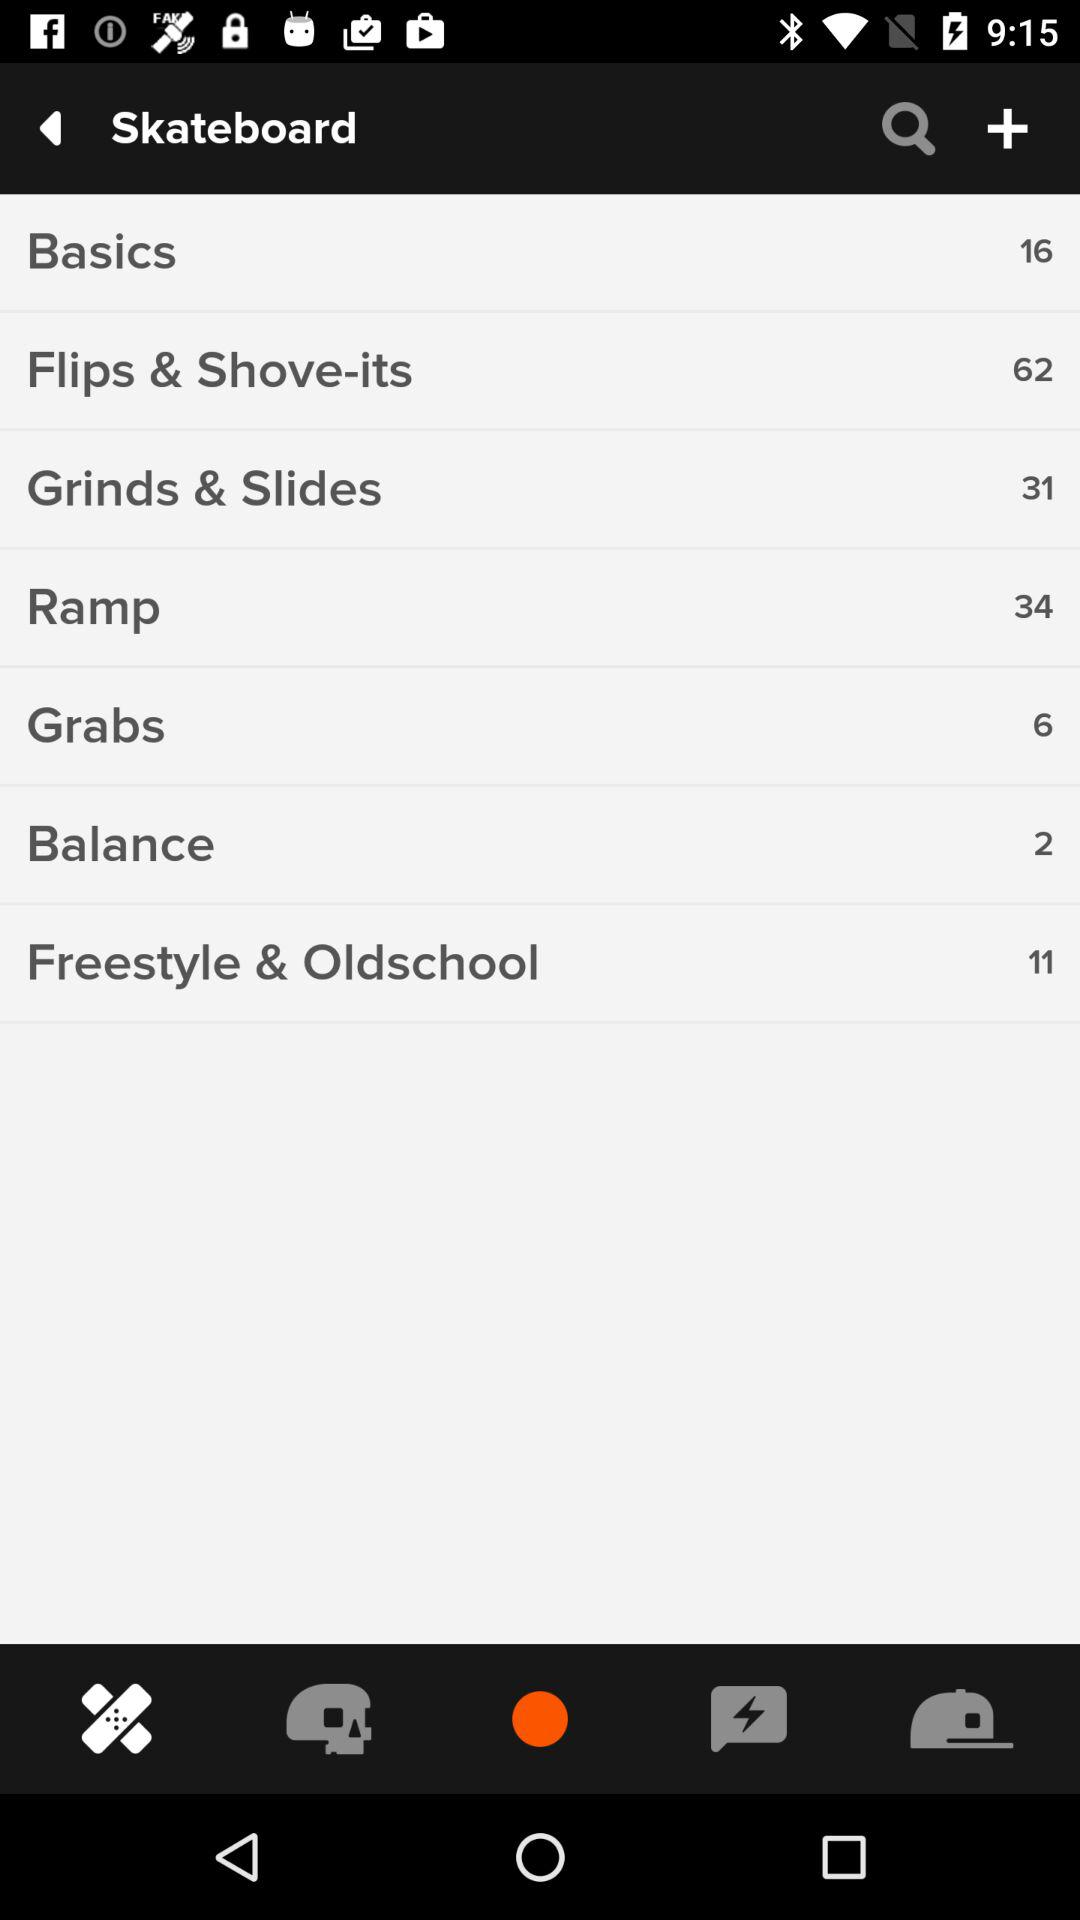How many "Grabs" tricks are there on a skateboard? There are 6 "Grabs" tricks. 